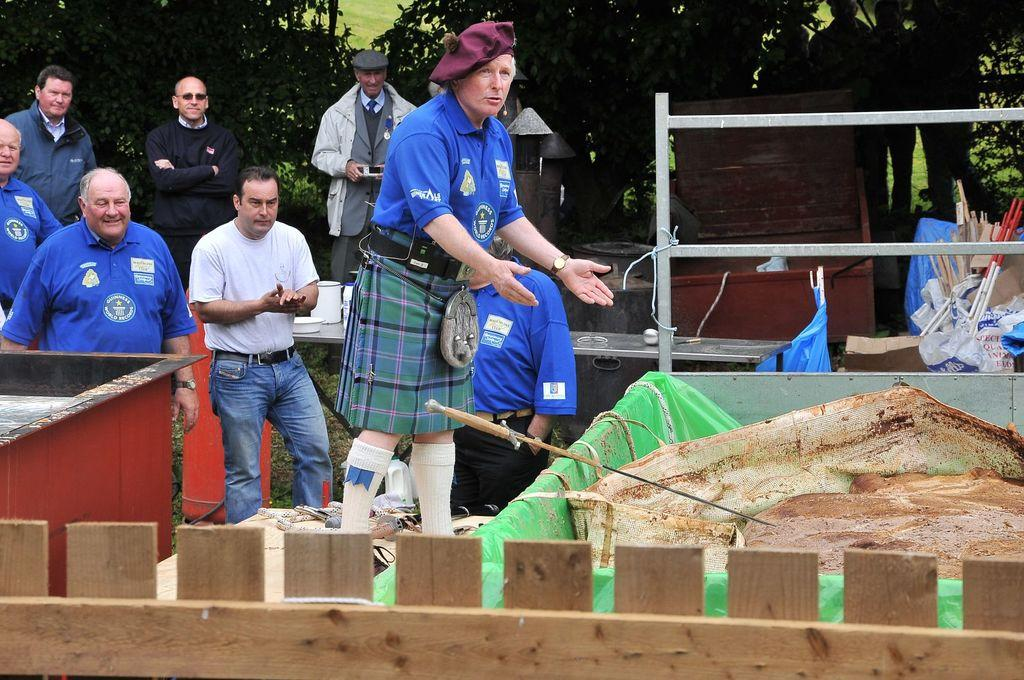What is the main subject of the picture? The main subject of the picture is a group of people. Can you describe the people in the picture? Most of the people in the picture are men. What can be seen in the background of the picture? There are trees in the background of the picture. What type of polish is being applied to the tank in the image? There is no tank or polish present in the image; it features a group of people and trees in the background. 